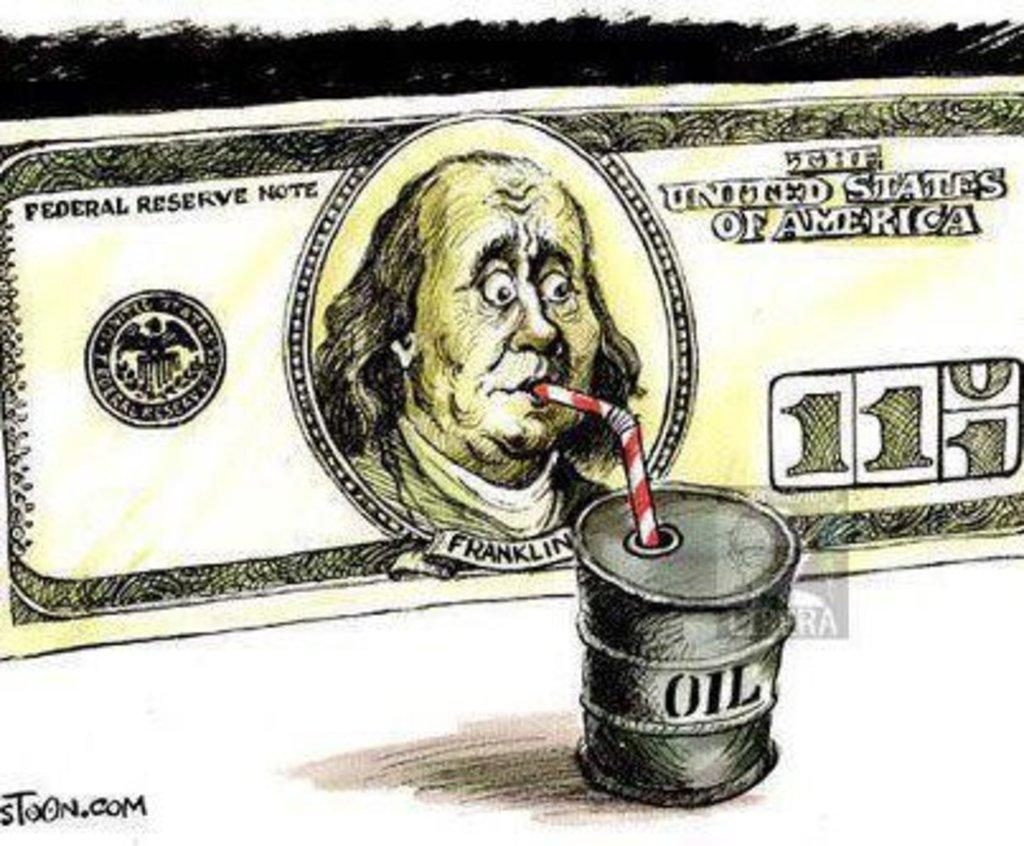What type of artwork is the image? The image is a painted picture. What object is depicted in the image? There is a dollar depicted in the image. What other object can be seen in the image? There is an oil tank in the image. What item is present in the image that might be used for drinking? There is a straw in the image. Where is the text located in the image? The text is in the corner of the image. How many frogs are sitting on the dollar in the image? There are no frogs present in the image; it features a dollar and an oil tank. What type of men can be seen walking in the background of the image? There are no men present in the image; it is a painted picture of a dollar and an oil tank. 